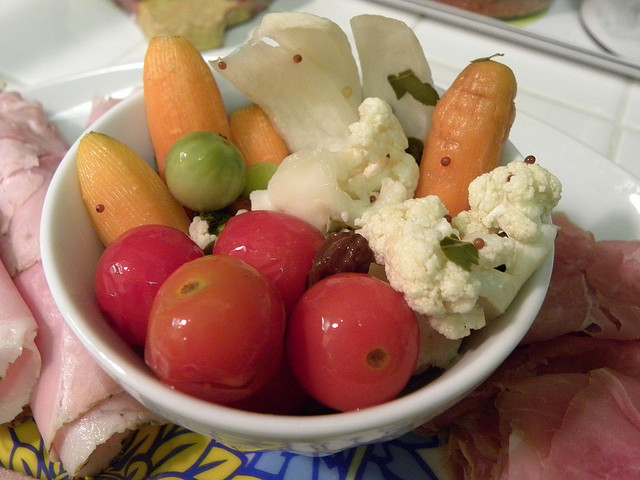<image>How many calories are in this bowl? I don't know how many calories are in this bowl. What fruits are in this picture? There are no real fruits in the picture. However, it can be tomato, cantaloupe, melon, papaya, plum or grapes. How many calories are in this bowl? I don't know how many calories are in this bowl. It can be any number. What fruits are in this picture? It is unknown what fruits are in the picture. There are no real fruits, but it can be seen tomatoes, papaya and grapes. 